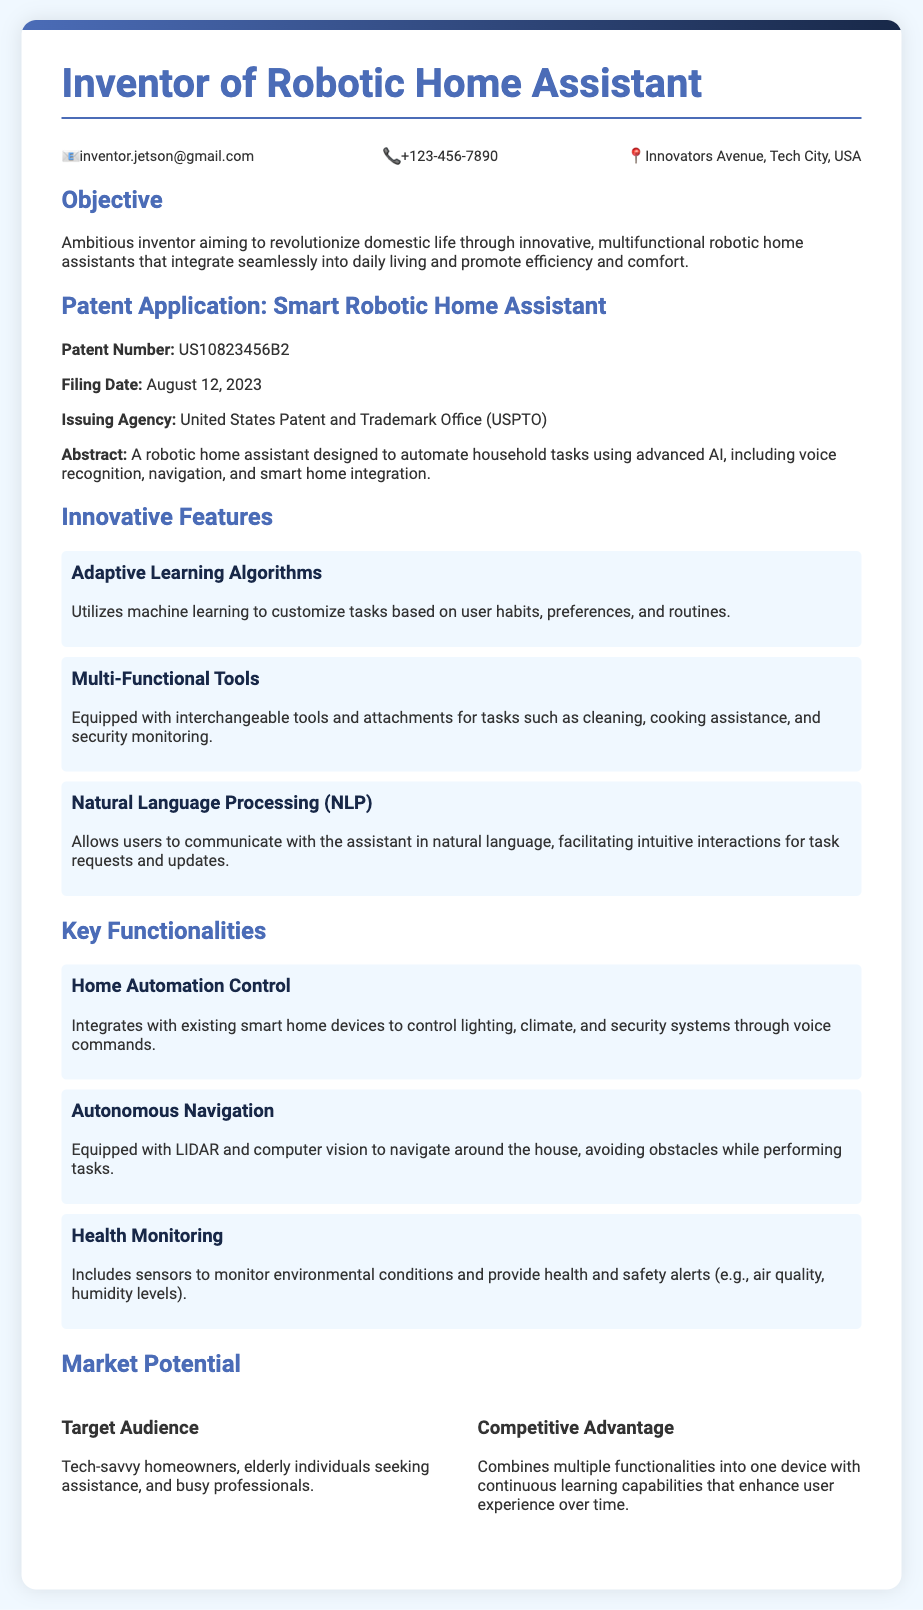what is the patent number? The patent number is listed in the "Patent Application" section of the document.
Answer: US10823456B2 when was the patent filed? The filing date is specified in the "Patent Application" section of the document.
Answer: August 12, 2023 who issued the patent? The issuing agency is mentioned in the "Patent Application" section of the document.
Answer: United States Patent and Trademark Office (USPTO) what technology does the robotic assistant use for navigation? The document specifies the technology used for navigation in the features listed.
Answer: LIDAR and computer vision what is one target audience for the product? The target audience is detailed in the "Market Potential" section of the document.
Answer: Tech-savvy homeowners how does the assistant communicate with users? The mode of communication is highlighted in the "Innovative Features" section.
Answer: Natural language what is a key functionality related to home automation? The capabilities relevant to home automation are mentioned in the functionalities.
Answer: Home Automation Control what is a competitive advantage of the robotic home assistant? The competitive advantage is elaborated upon in the "Market Potential" section.
Answer: Continuous learning capabilities what feature allows the assistant to customize tasks? The feature responsible for customization of tasks is discussed in the innovative features.
Answer: Adaptive Learning Algorithms 